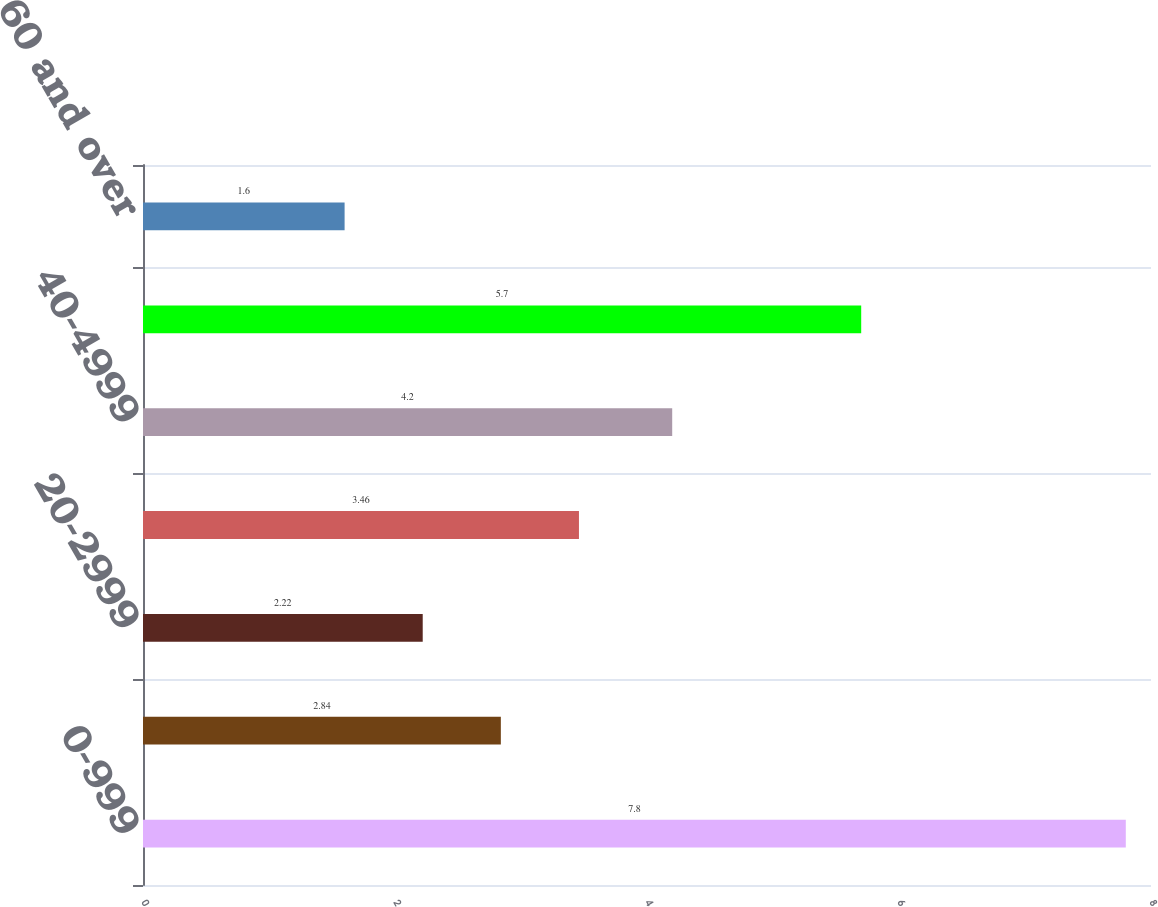Convert chart to OTSL. <chart><loc_0><loc_0><loc_500><loc_500><bar_chart><fcel>0-999<fcel>10-1999<fcel>20-2999<fcel>30-3999<fcel>40-4999<fcel>50-5999<fcel>60 and over<nl><fcel>7.8<fcel>2.84<fcel>2.22<fcel>3.46<fcel>4.2<fcel>5.7<fcel>1.6<nl></chart> 